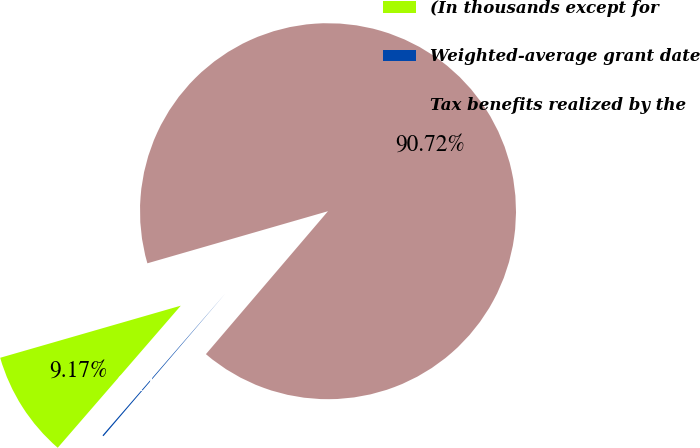<chart> <loc_0><loc_0><loc_500><loc_500><pie_chart><fcel>(In thousands except for<fcel>Weighted-average grant date<fcel>Tax benefits realized by the<nl><fcel>9.17%<fcel>0.11%<fcel>90.72%<nl></chart> 